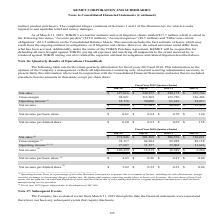According to Kemet Corporation's financial document, What was the net sales for the Jun-30 quarter? According to the financial document, 327,616 (in thousands). The relevant text states: "Net sales $ 327,616 $ 349,233 $ 350,175 $ 355,794..." Also, What was the gross margin for the Sep-30 quarter? According to the financial document, 113,565 (in thousands). The relevant text states: "Gross margin 94,821 113,565 123,750 126,406..." Also, What was the operating income for the Mar-31 quarter? According to the financial document, 54,057 (in thousands). The relevant text states: "Operating income (1) 35,176 50,000 61,616 54,057..." Also, can you calculate: What was the change in the Net sales between the Dec-31 and Mar-31 quarters? Based on the calculation: 355,794-350,175, the result is 5619 (in thousands). This is based on the information: "Net sales $ 327,616 $ 349,233 $ 350,175 $ 355,794 Net sales $ 327,616 $ 349,233 $ 350,175 $ 355,794..." The key data points involved are: 350,175, 355,794. Additionally, Which quarters ended did the Gross Margin exceed $120,000 thousand? The document shows two values: Dec-31 and Mar-31. From the document: "Jun-30 Sep-30 Dec-31 Mar-31 Jun-30 Sep-30 Dec-31 Mar-31..." Also, can you calculate: What was the percentage change in the net income between the Jun-30 and Sep-30 quarter? To answer this question, I need to perform calculations using the financial data. The calculation is: (37,141-35,220)/35,220, which equals 5.45 (percentage). This is based on the information: "Net income $ 35,220 $ 37,141 $ 40,806 $ 93,420 Net income $ 35,220 $ 37,141 $ 40,806 $ 93,420..." The key data points involved are: 35,220, 37,141. 